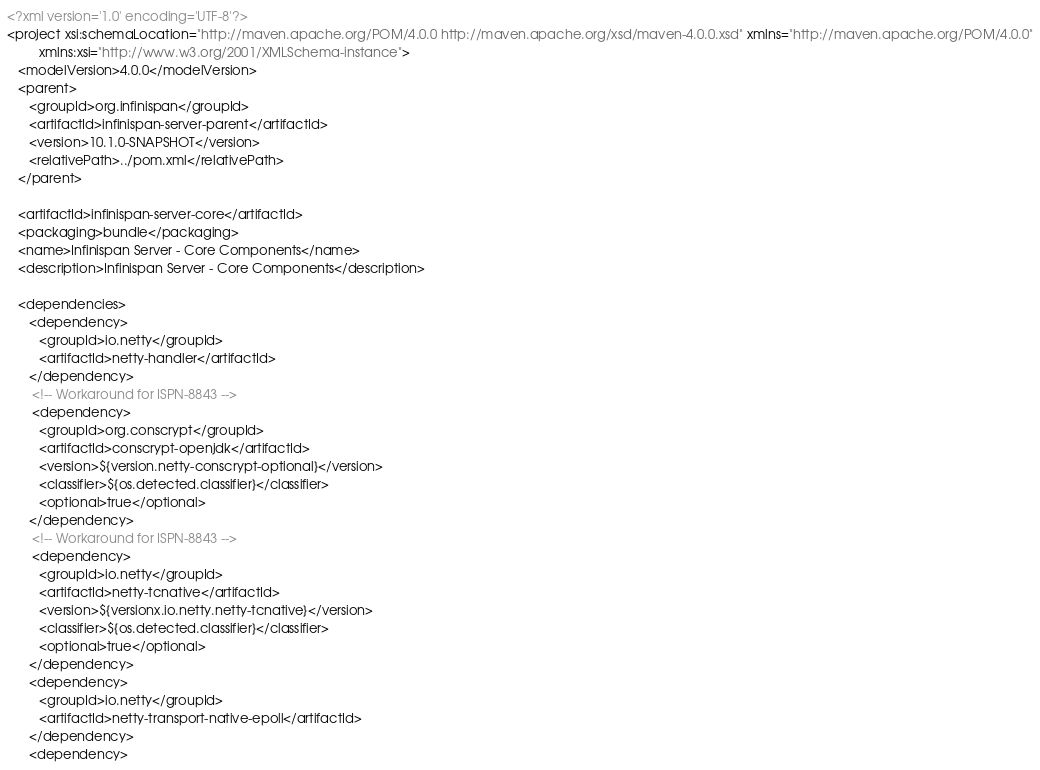Convert code to text. <code><loc_0><loc_0><loc_500><loc_500><_XML_><?xml version='1.0' encoding='UTF-8'?>
<project xsi:schemaLocation="http://maven.apache.org/POM/4.0.0 http://maven.apache.org/xsd/maven-4.0.0.xsd" xmlns="http://maven.apache.org/POM/4.0.0"
         xmlns:xsi="http://www.w3.org/2001/XMLSchema-instance">
   <modelVersion>4.0.0</modelVersion>
   <parent>
      <groupId>org.infinispan</groupId>
      <artifactId>infinispan-server-parent</artifactId>
      <version>10.1.0-SNAPSHOT</version>
      <relativePath>../pom.xml</relativePath>
   </parent>

   <artifactId>infinispan-server-core</artifactId>
   <packaging>bundle</packaging>
   <name>Infinispan Server - Core Components</name>
   <description>Infinispan Server - Core Components</description>

   <dependencies>
      <dependency>
         <groupId>io.netty</groupId>
         <artifactId>netty-handler</artifactId>
      </dependency>
       <!-- Workaround for ISPN-8843 -->
       <dependency>
         <groupId>org.conscrypt</groupId>
         <artifactId>conscrypt-openjdk</artifactId>
         <version>${version.netty-conscrypt-optional}</version>
         <classifier>${os.detected.classifier}</classifier>
         <optional>true</optional>
      </dependency>
       <!-- Workaround for ISPN-8843 -->
       <dependency>
         <groupId>io.netty</groupId>
         <artifactId>netty-tcnative</artifactId>
         <version>${versionx.io.netty.netty-tcnative}</version>
         <classifier>${os.detected.classifier}</classifier>
         <optional>true</optional>
      </dependency>
      <dependency>
         <groupId>io.netty</groupId>
         <artifactId>netty-transport-native-epoll</artifactId>
      </dependency>
      <dependency></code> 